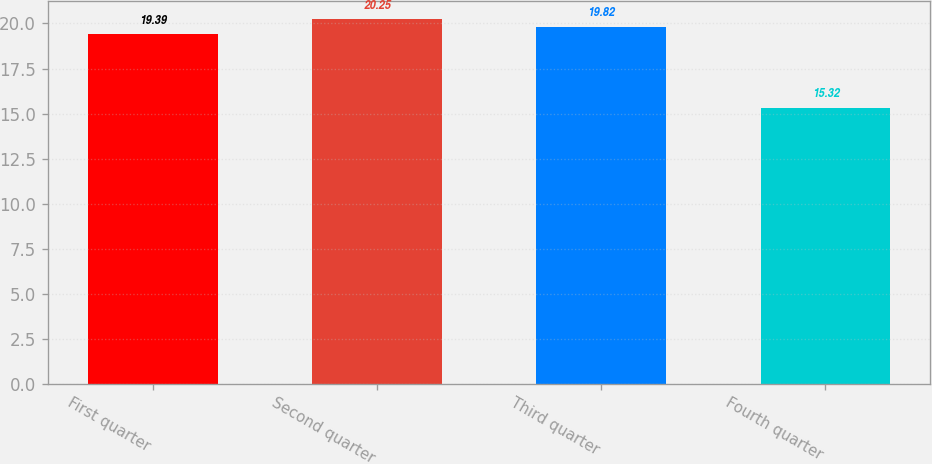Convert chart to OTSL. <chart><loc_0><loc_0><loc_500><loc_500><bar_chart><fcel>First quarter<fcel>Second quarter<fcel>Third quarter<fcel>Fourth quarter<nl><fcel>19.39<fcel>20.25<fcel>19.82<fcel>15.32<nl></chart> 